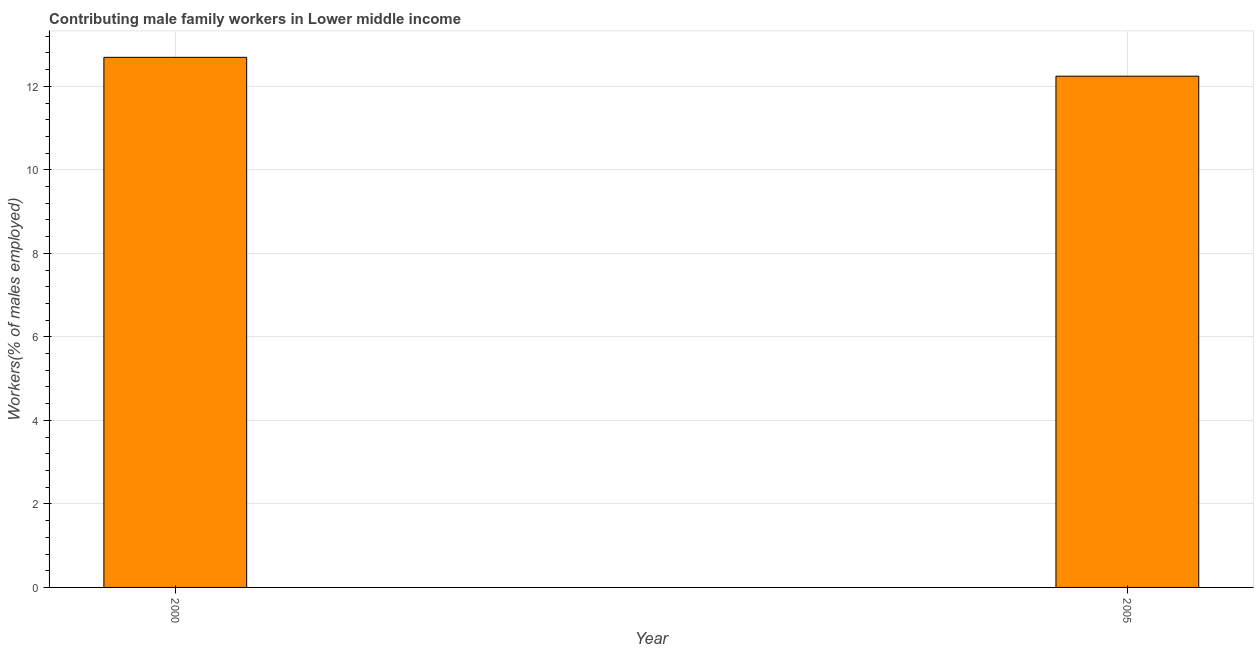What is the title of the graph?
Offer a terse response. Contributing male family workers in Lower middle income. What is the label or title of the Y-axis?
Ensure brevity in your answer.  Workers(% of males employed). What is the contributing male family workers in 2005?
Your answer should be very brief. 12.24. Across all years, what is the maximum contributing male family workers?
Offer a very short reply. 12.69. Across all years, what is the minimum contributing male family workers?
Ensure brevity in your answer.  12.24. What is the sum of the contributing male family workers?
Your answer should be very brief. 24.94. What is the difference between the contributing male family workers in 2000 and 2005?
Offer a very short reply. 0.45. What is the average contributing male family workers per year?
Your response must be concise. 12.47. What is the median contributing male family workers?
Provide a short and direct response. 12.47. In how many years, is the contributing male family workers greater than 7.6 %?
Give a very brief answer. 2. Is the contributing male family workers in 2000 less than that in 2005?
Keep it short and to the point. No. In how many years, is the contributing male family workers greater than the average contributing male family workers taken over all years?
Your answer should be compact. 1. What is the Workers(% of males employed) in 2000?
Your answer should be very brief. 12.69. What is the Workers(% of males employed) of 2005?
Give a very brief answer. 12.24. What is the difference between the Workers(% of males employed) in 2000 and 2005?
Your response must be concise. 0.45. What is the ratio of the Workers(% of males employed) in 2000 to that in 2005?
Your answer should be very brief. 1.04. 